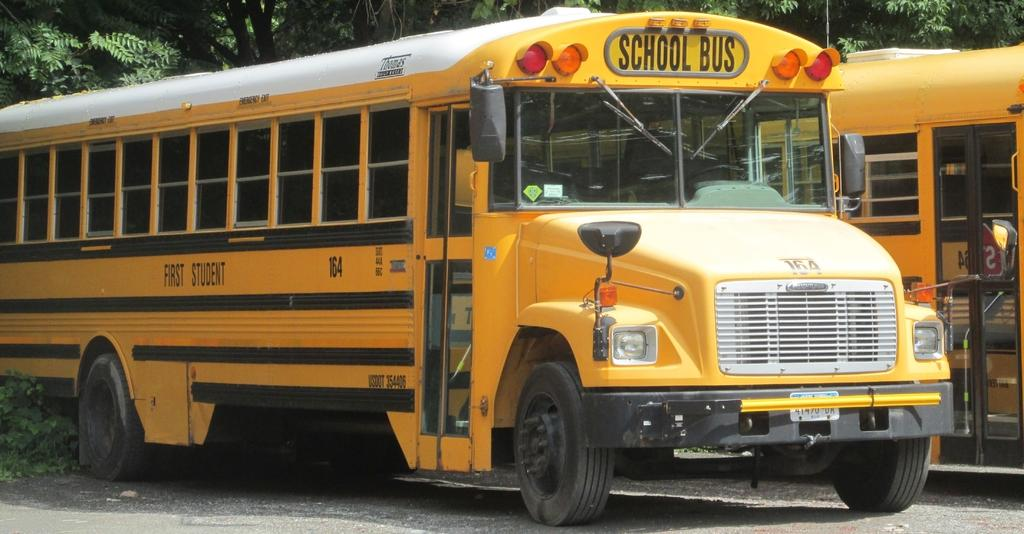How many school buses are visible in the image? There are two yellow school buses in the image. What color are the school buses? The school buses are yellow. What can be seen in the background of the image? The background of the image contains trees. What type of truck can be seen carrying an icicle in the image? There is no truck or icicle present in the image; it only features two yellow school buses and trees in the background. 